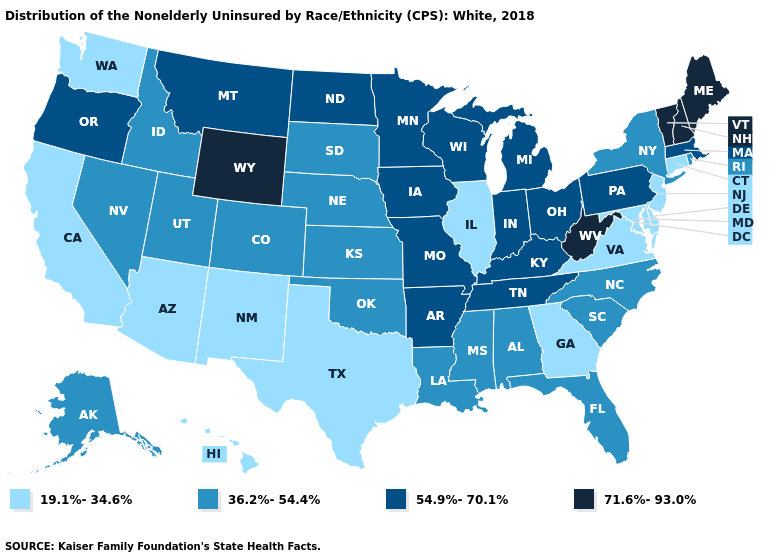Which states have the lowest value in the USA?
Answer briefly. Arizona, California, Connecticut, Delaware, Georgia, Hawaii, Illinois, Maryland, New Jersey, New Mexico, Texas, Virginia, Washington. What is the value of California?
Be succinct. 19.1%-34.6%. Does Colorado have the same value as West Virginia?
Short answer required. No. What is the lowest value in states that border Alabama?
Keep it brief. 19.1%-34.6%. What is the lowest value in the South?
Write a very short answer. 19.1%-34.6%. Does the map have missing data?
Keep it brief. No. Does Nevada have the highest value in the West?
Give a very brief answer. No. What is the value of Maryland?
Answer briefly. 19.1%-34.6%. What is the value of Virginia?
Concise answer only. 19.1%-34.6%. Name the states that have a value in the range 54.9%-70.1%?
Give a very brief answer. Arkansas, Indiana, Iowa, Kentucky, Massachusetts, Michigan, Minnesota, Missouri, Montana, North Dakota, Ohio, Oregon, Pennsylvania, Tennessee, Wisconsin. What is the highest value in states that border North Dakota?
Keep it brief. 54.9%-70.1%. Does Pennsylvania have the lowest value in the Northeast?
Answer briefly. No. What is the highest value in states that border Wyoming?
Be succinct. 54.9%-70.1%. Does the first symbol in the legend represent the smallest category?
Short answer required. Yes. Does Georgia have the lowest value in the South?
Quick response, please. Yes. 